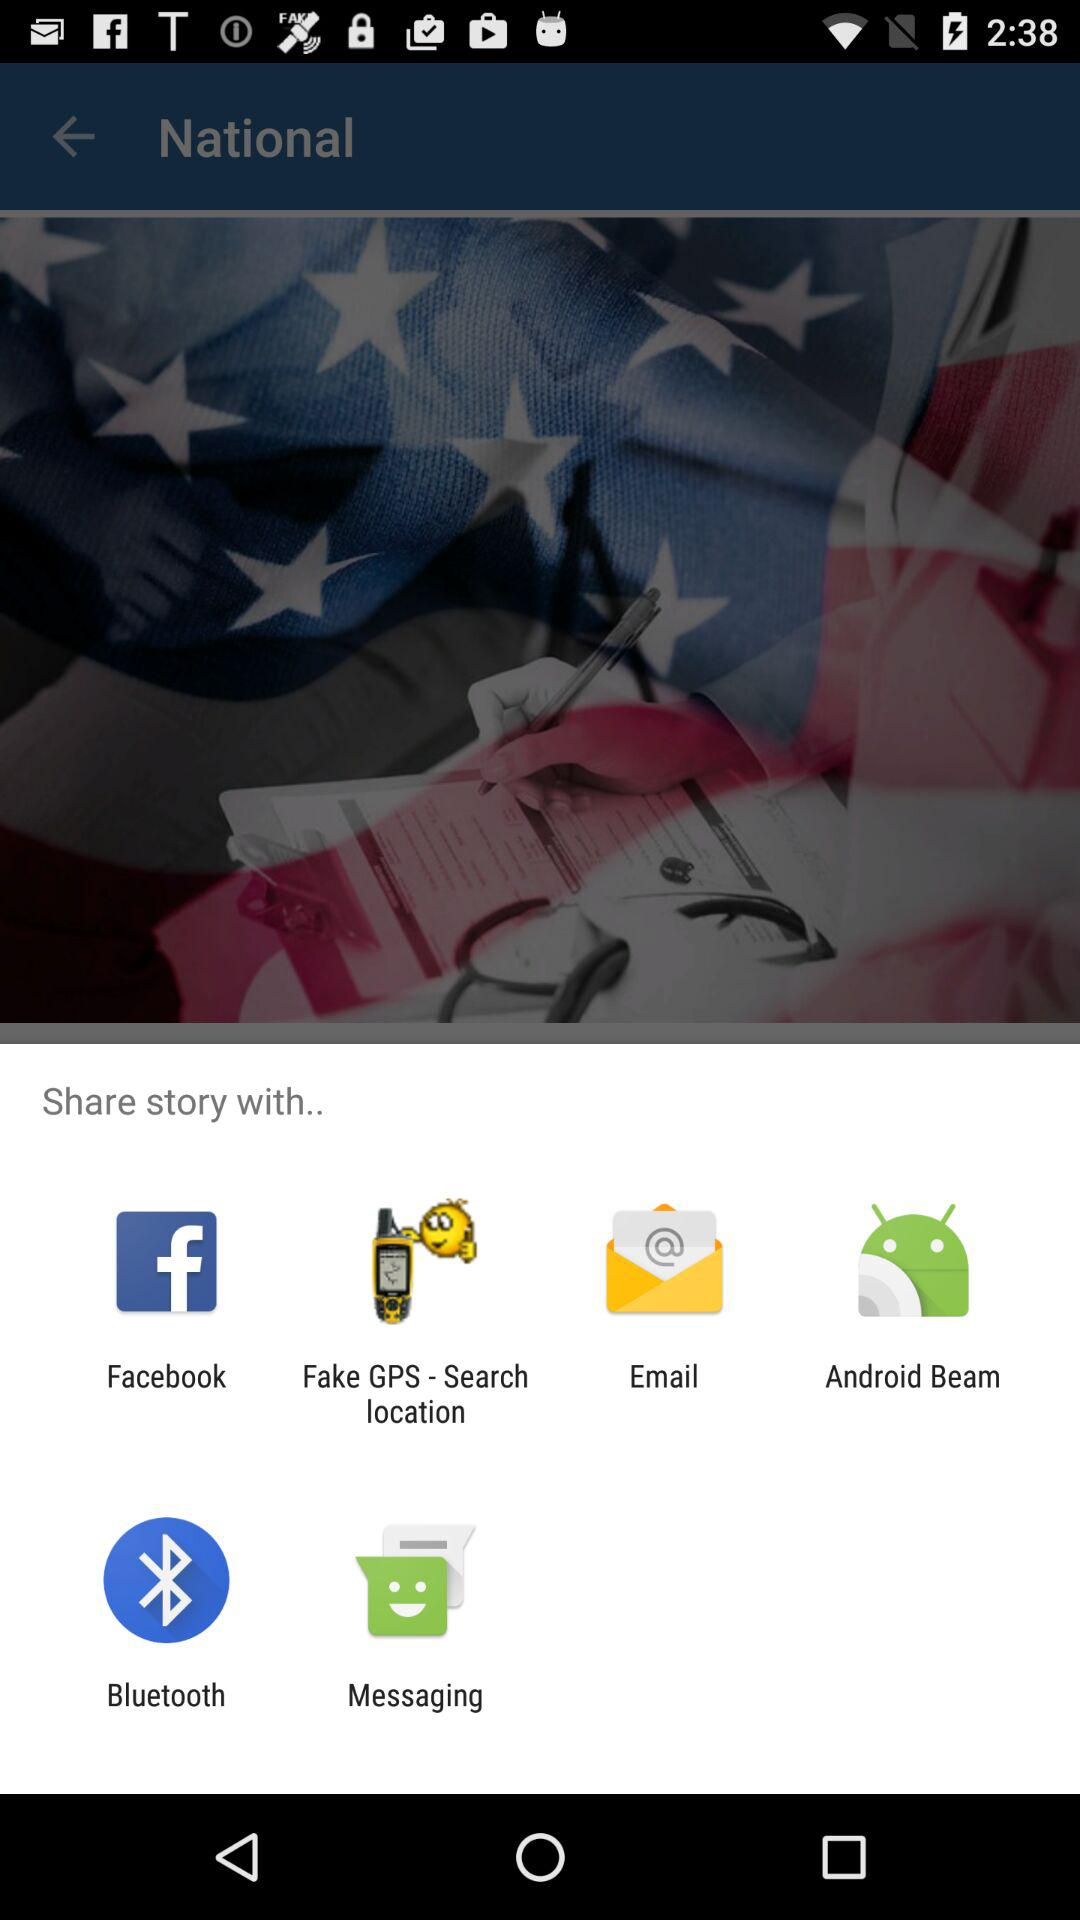Which version of the application is this?
When the provided information is insufficient, respond with <no answer>. <no answer> 